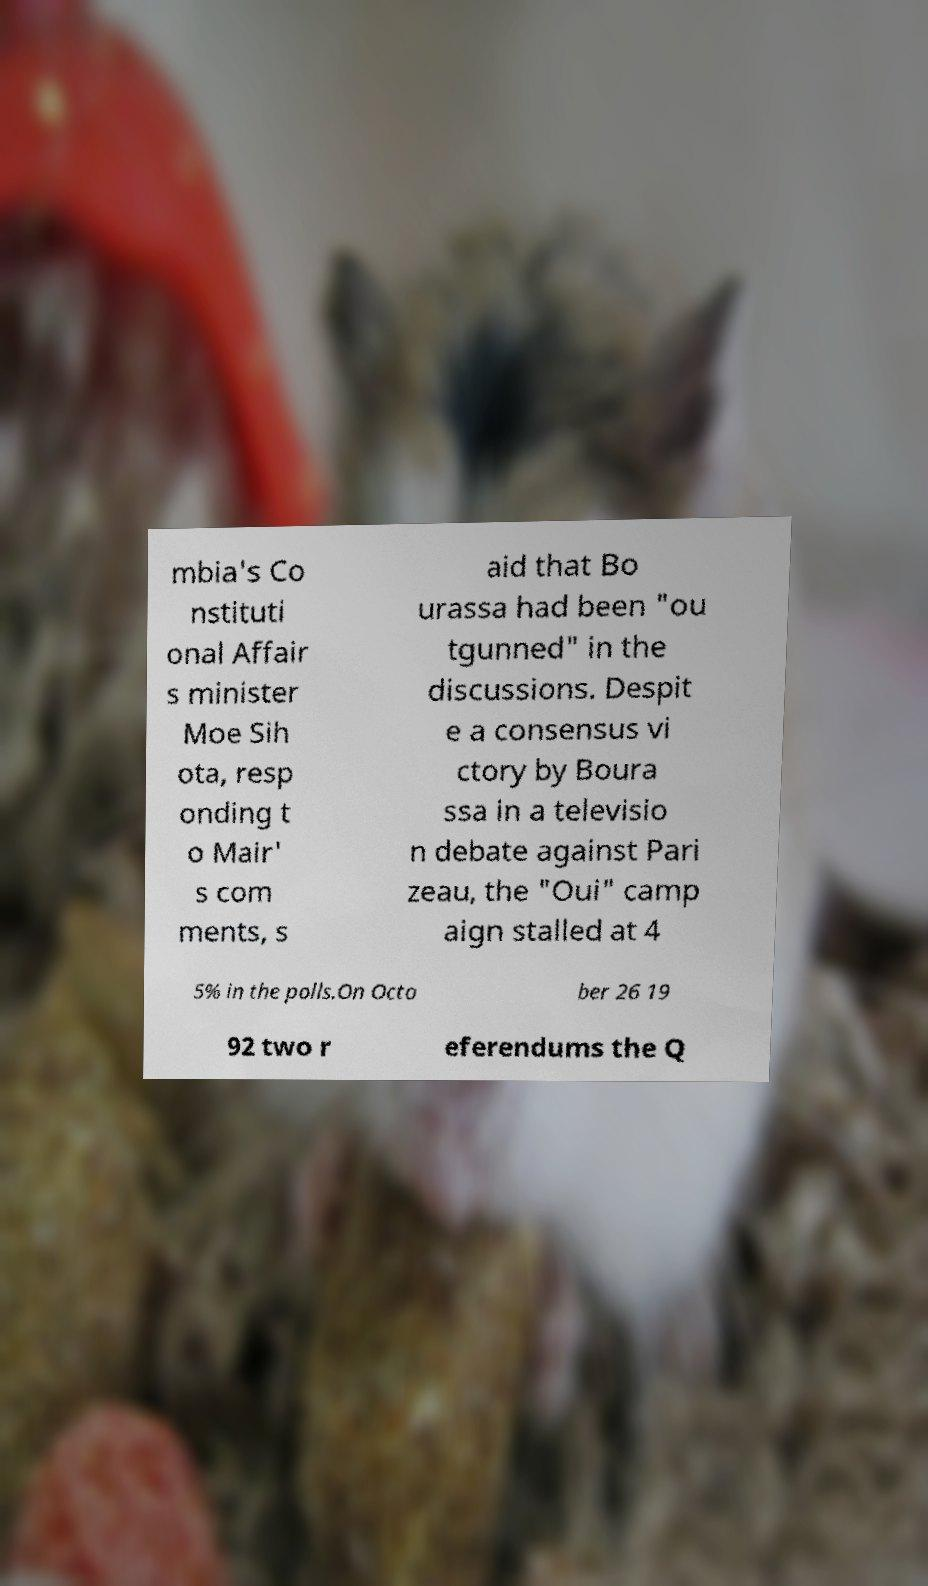Please read and relay the text visible in this image. What does it say? mbia's Co nstituti onal Affair s minister Moe Sih ota, resp onding t o Mair' s com ments, s aid that Bo urassa had been "ou tgunned" in the discussions. Despit e a consensus vi ctory by Boura ssa in a televisio n debate against Pari zeau, the "Oui" camp aign stalled at 4 5% in the polls.On Octo ber 26 19 92 two r eferendums the Q 